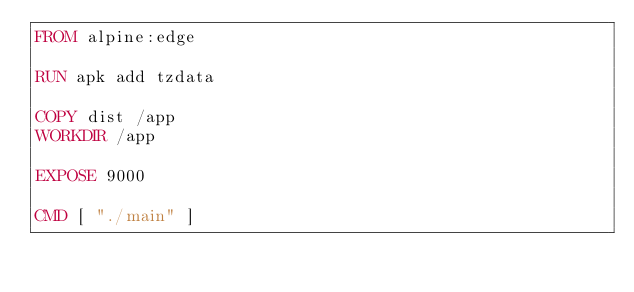Convert code to text. <code><loc_0><loc_0><loc_500><loc_500><_Dockerfile_>FROM alpine:edge

RUN apk add tzdata

COPY dist /app
WORKDIR /app

EXPOSE 9000

CMD [ "./main" ]</code> 